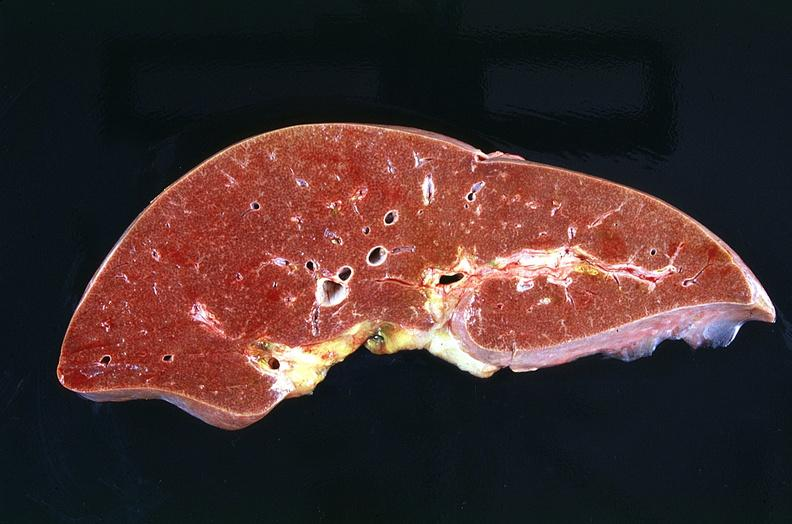s hepatobiliary present?
Answer the question using a single word or phrase. Yes 